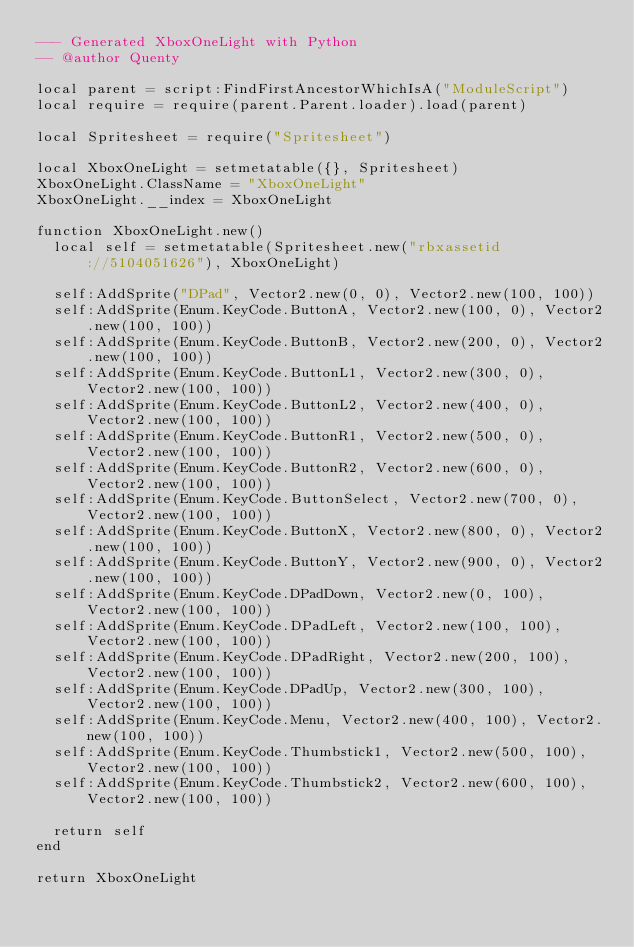Convert code to text. <code><loc_0><loc_0><loc_500><loc_500><_Lua_>--- Generated XboxOneLight with Python
-- @author Quenty

local parent = script:FindFirstAncestorWhichIsA("ModuleScript")
local require = require(parent.Parent.loader).load(parent)

local Spritesheet = require("Spritesheet")

local XboxOneLight = setmetatable({}, Spritesheet)
XboxOneLight.ClassName = "XboxOneLight"
XboxOneLight.__index = XboxOneLight

function XboxOneLight.new()
	local self = setmetatable(Spritesheet.new("rbxassetid://5104051626"), XboxOneLight)

	self:AddSprite("DPad", Vector2.new(0, 0), Vector2.new(100, 100))
	self:AddSprite(Enum.KeyCode.ButtonA, Vector2.new(100, 0), Vector2.new(100, 100))
	self:AddSprite(Enum.KeyCode.ButtonB, Vector2.new(200, 0), Vector2.new(100, 100))
	self:AddSprite(Enum.KeyCode.ButtonL1, Vector2.new(300, 0), Vector2.new(100, 100))
	self:AddSprite(Enum.KeyCode.ButtonL2, Vector2.new(400, 0), Vector2.new(100, 100))
	self:AddSprite(Enum.KeyCode.ButtonR1, Vector2.new(500, 0), Vector2.new(100, 100))
	self:AddSprite(Enum.KeyCode.ButtonR2, Vector2.new(600, 0), Vector2.new(100, 100))
	self:AddSprite(Enum.KeyCode.ButtonSelect, Vector2.new(700, 0), Vector2.new(100, 100))
	self:AddSprite(Enum.KeyCode.ButtonX, Vector2.new(800, 0), Vector2.new(100, 100))
	self:AddSprite(Enum.KeyCode.ButtonY, Vector2.new(900, 0), Vector2.new(100, 100))
	self:AddSprite(Enum.KeyCode.DPadDown, Vector2.new(0, 100), Vector2.new(100, 100))
	self:AddSprite(Enum.KeyCode.DPadLeft, Vector2.new(100, 100), Vector2.new(100, 100))
	self:AddSprite(Enum.KeyCode.DPadRight, Vector2.new(200, 100), Vector2.new(100, 100))
	self:AddSprite(Enum.KeyCode.DPadUp, Vector2.new(300, 100), Vector2.new(100, 100))
	self:AddSprite(Enum.KeyCode.Menu, Vector2.new(400, 100), Vector2.new(100, 100))
	self:AddSprite(Enum.KeyCode.Thumbstick1, Vector2.new(500, 100), Vector2.new(100, 100))
	self:AddSprite(Enum.KeyCode.Thumbstick2, Vector2.new(600, 100), Vector2.new(100, 100))

	return self
end

return XboxOneLight
</code> 